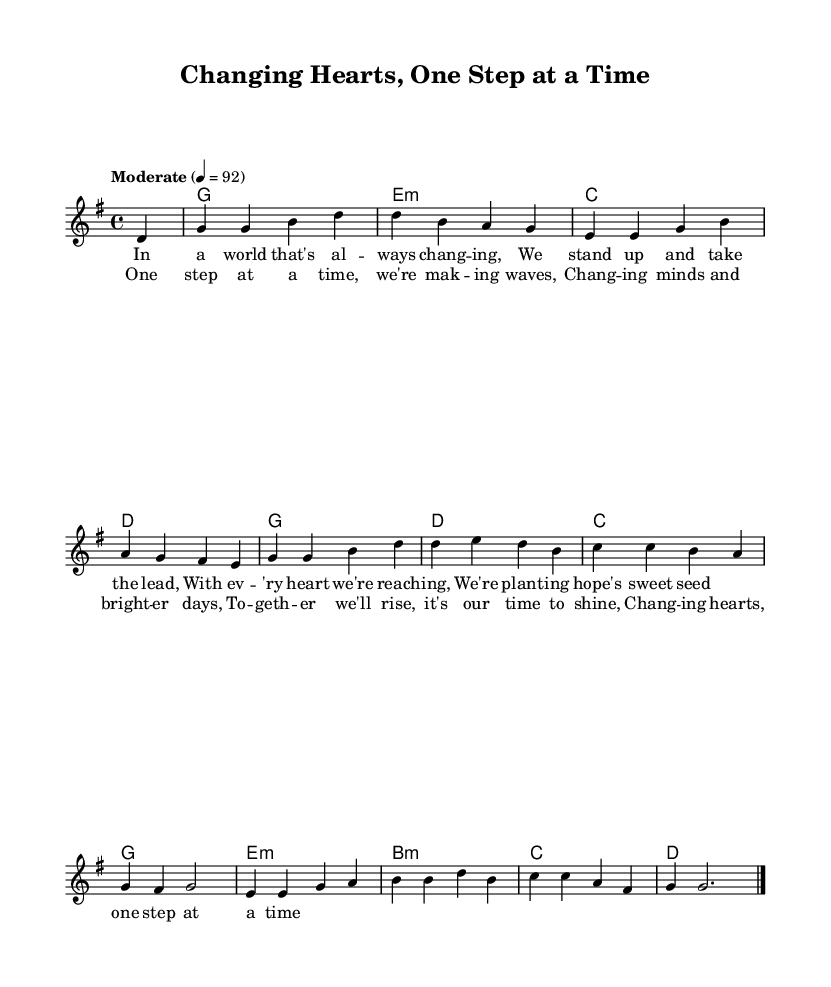What is the key signature of this music? The key signature is G major, which has one sharp (F#). This can be determined by looking at the initial measure in the sheet music where the key signature is indicated.
Answer: G major What is the time signature of this music? The time signature is 4/4, which is noted at the beginning of the score. This means there are four beats per measure and a quarter note receives one beat.
Answer: 4/4 What is the tempo marking for this piece? The tempo marking is "Moderate" at a rate of 92 beats per minute, specified in the tempo indication at the start of the music.
Answer: Moderate 4 = 92 How many measures does the verse consist of? The verse consists of 4 measures, which can be counted by looking at the number of bar lines present in the melody section.
Answer: 4 measures What is the main theme of the lyrics? The main theme of the lyrics is about hope and perseverance, highlighted in the discussions of standing up and making a difference. This can be inferred from the text in the verse and chorus provided.
Answer: Hope and perseverance In what way does the chorus emphasize unity? The chorus emphasizes unity by using the phrase "One step at a time" and "Together we'll rise," which highlights collective action and support among individuals facing challenges. This can be understood by analyzing the wording and its encouraging nature in the lyrics.
Answer: Collective action What chord is used most frequently in the harmonies? The chord used most frequently in the harmonies is G major, as seen by its repeated occurrence throughout the chord changes in the piece.
Answer: G major 